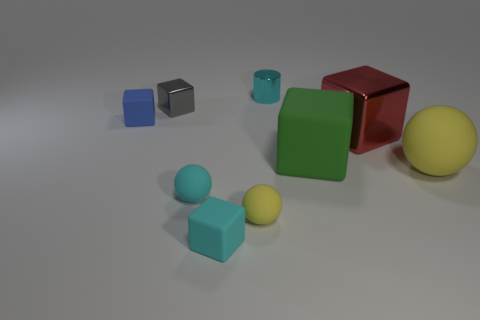What number of rubber balls have the same color as the cylinder?
Keep it short and to the point. 1. What shape is the rubber object left of the metal cube that is behind the block that is to the left of the gray block?
Provide a succinct answer. Cube. How many objects are either small blue things or small yellow spheres?
Provide a succinct answer. 2. Do the large rubber thing that is on the left side of the big metal cube and the object that is on the left side of the tiny metal cube have the same shape?
Offer a terse response. Yes. How many tiny shiny objects are in front of the tiny cyan shiny thing and right of the small cyan matte sphere?
Ensure brevity in your answer.  0. What number of other things are there of the same size as the red block?
Ensure brevity in your answer.  2. What material is the tiny thing that is both behind the green thing and in front of the gray shiny cube?
Provide a short and direct response. Rubber. Is the color of the big shiny thing the same as the metal cube behind the blue rubber thing?
Give a very brief answer. No. There is a green object that is the same shape as the tiny gray thing; what size is it?
Ensure brevity in your answer.  Large. The tiny cyan thing that is behind the small yellow object and in front of the large red metallic thing has what shape?
Your answer should be compact. Sphere. 